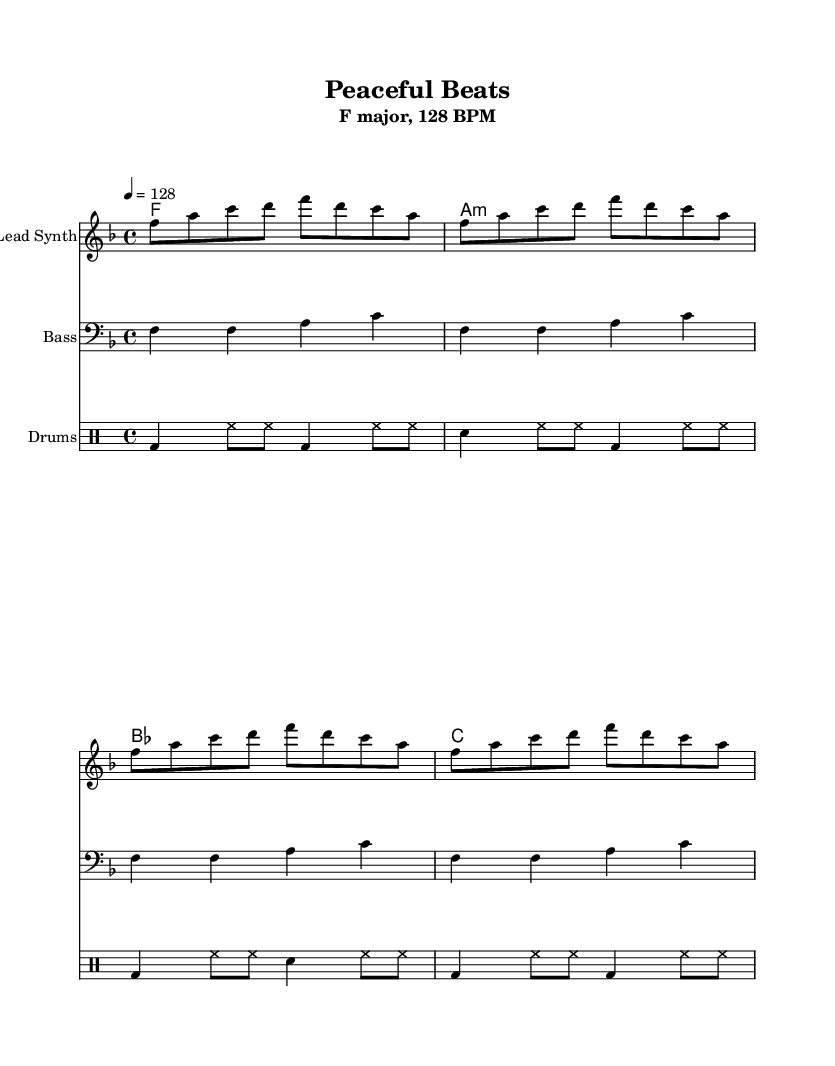What is the key signature of this music? The key signature is F major, which has one flat (B flat). This can be identified from the initial signature placed at the beginning of the staff, indicating F major.
Answer: F major What is the time signature of this music? The time signature is 4/4, which indicates there are four beats in each measure and the quarter note gets one beat. This is shown at the start of the score.
Answer: 4/4 What is the tempo marking of this music? The tempo marking is 128 BPM, indicating the speed at which the piece should be played. This is specified in the tempo section of the score as “4 = 128.”
Answer: 128 BPM How many measures are in the lead synth part? The lead synth part consists of four measures, which can be counted by identifying each segment of notes separated by vertical lines in the staff.
Answer: Four measures Which chord appears last in the chord progression? The last chord in the progression is C major, as seen in the chord names section at the end of the chord progression written out.
Answer: C major What type of rhythmic pattern is primarily used in the drum part? The rhythmic pattern in the drum part primarily consists of alternating bass drum (bd) and hi-hat (hh) sounds with a snare (sn) interspersed. This is characterized by a consistent eighth and quarter note pattern typical in house music.
Answer: Alternating pattern How does the bassline relate to the overall harmony of the track? The bassline complements the harmonic structure by playing root notes of the chords listed. It solidifies the harmony by reinforcing F, A, and C notes, which correspond to the chords in the progression.
Answer: It reinforces harmony 